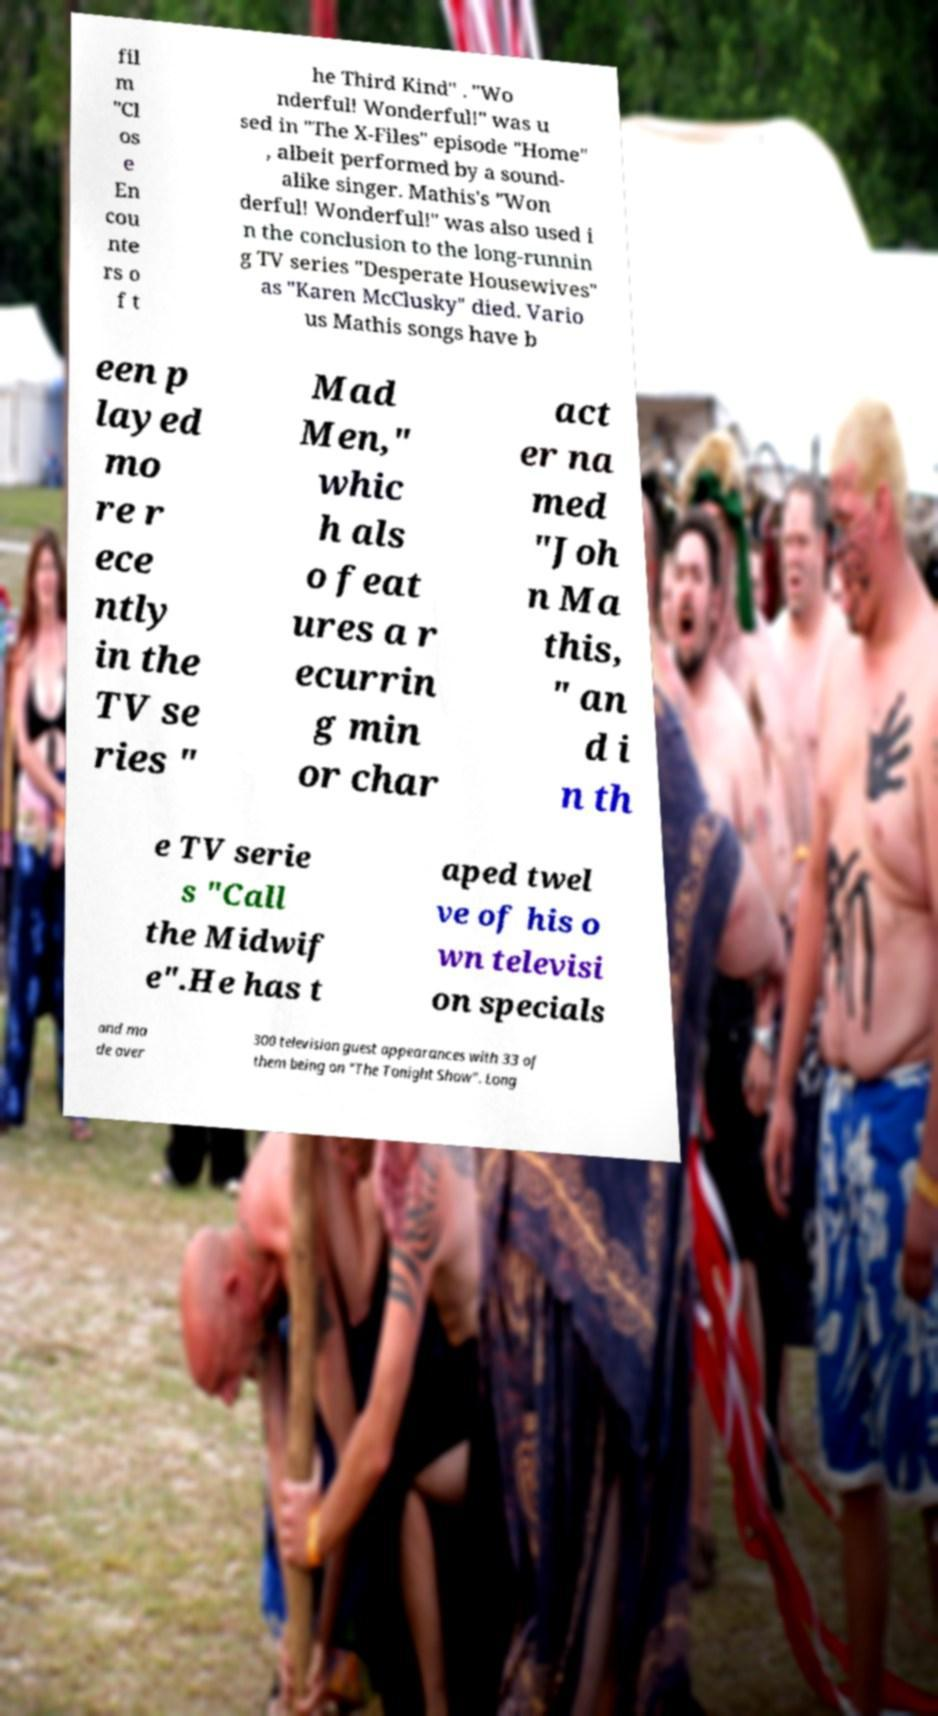Please read and relay the text visible in this image. What does it say? fil m "Cl os e En cou nte rs o f t he Third Kind" . "Wo nderful! Wonderful!" was u sed in "The X-Files" episode "Home" , albeit performed by a sound- alike singer. Mathis's "Won derful! Wonderful!" was also used i n the conclusion to the long-runnin g TV series "Desperate Housewives" as "Karen McClusky" died. Vario us Mathis songs have b een p layed mo re r ece ntly in the TV se ries " Mad Men," whic h als o feat ures a r ecurrin g min or char act er na med "Joh n Ma this, " an d i n th e TV serie s "Call the Midwif e".He has t aped twel ve of his o wn televisi on specials and ma de over 300 television guest appearances with 33 of them being on "The Tonight Show". Long 